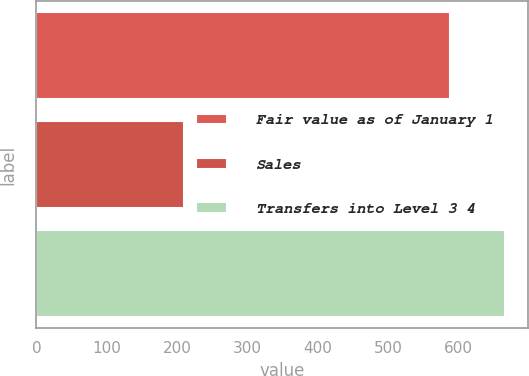Convert chart. <chart><loc_0><loc_0><loc_500><loc_500><bar_chart><fcel>Fair value as of January 1<fcel>Sales<fcel>Transfers into Level 3 4<nl><fcel>588<fcel>210<fcel>666<nl></chart> 